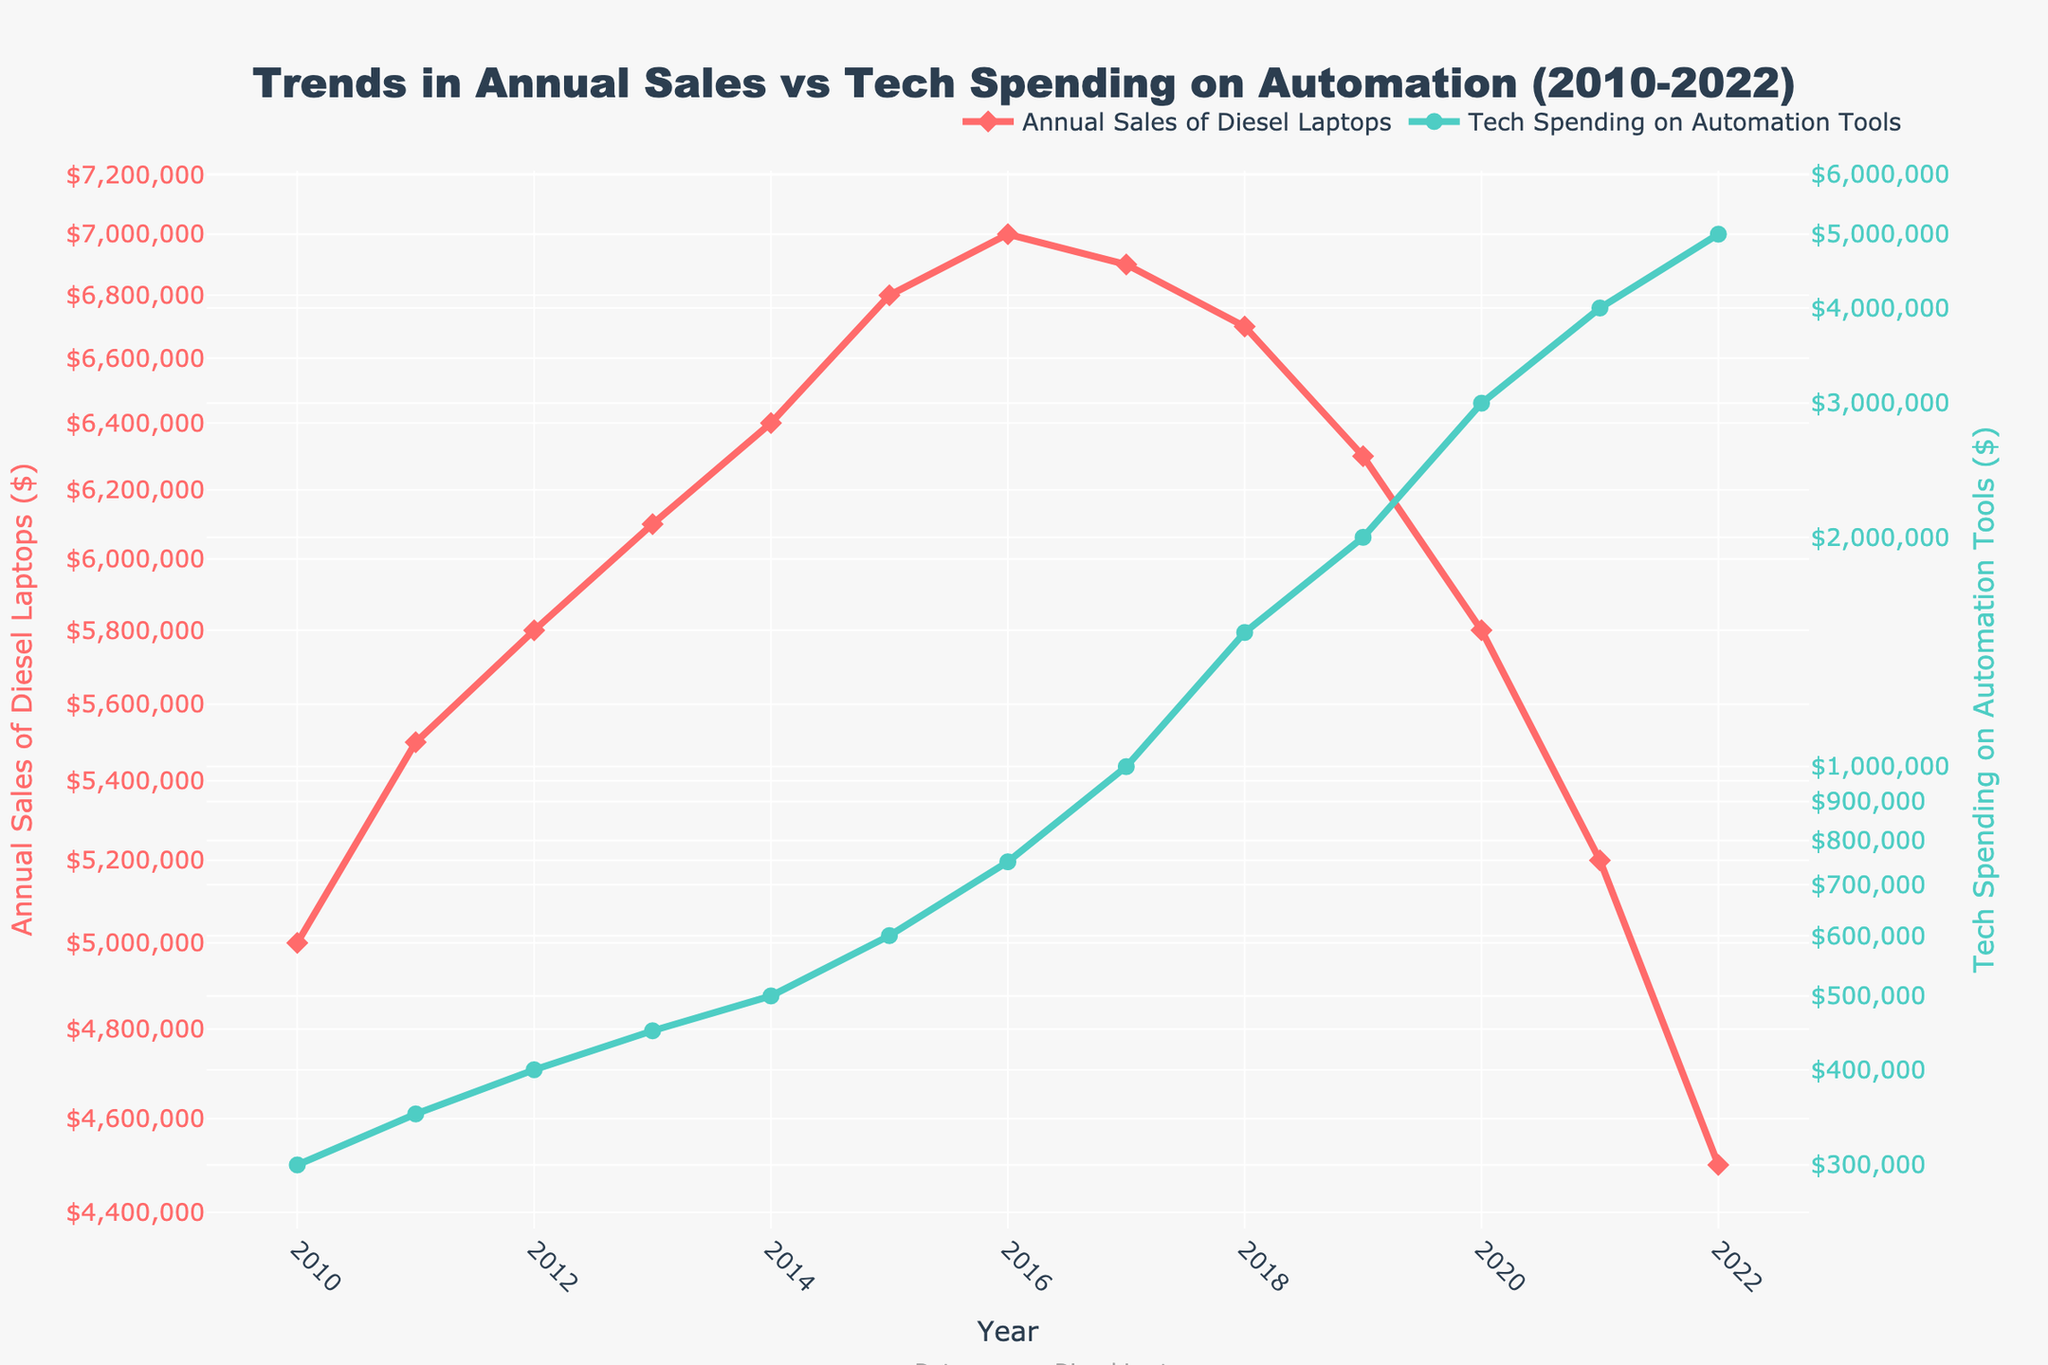What is the title of the plot? The title is positioned above the plot and is designed to give a summary of the data being visualized.
Answer: Trends in Annual Sales vs Tech Spending on Automation (2010-2022) How many data points are displayed for Annual Sales of Diesel Laptops? Each year from 2010 to 2022 is marked with a data point in the figure. Counting all the data points within the specified range provides the answer.
Answer: 13 What trend do you observe in Tech Spending on Automation Tools from 2015 to 2022? By examining the figure's log-scale axis, look at the trace for Tech Spending on Automation Tools. Observing the pattern from 2015 to 2022 shows the trend.
Answer: Increasing What was the annual sales value of Diesel Laptops in 2012? Find the data point for the year 2012 in the trace for Annual Sales of Diesel Laptops. The value is marked at this data point.
Answer: $5,800,000 In which year did Tech Spending on Automation Tools exceed $1,000,000 for the first time? Locate the point where the trace for Tech Spending on Automation Tools crosses the $1,000,000 mark on the log-scale axis. Identify the corresponding year.
Answer: 2017 What is the relationship between the trends in the two variables from 2018 to 2022? Analyze the patterns of both trends over these years. Annual Sales of Diesel Laptops appear to decrease, while Tech Spending on Automation Tools appears to increase.
Answer: Inversely proportional Which had a larger percentage change from 2010 to 2022, Annual Sales of Diesel Laptops or Tech Spending on Automation Tools? Calculate the percentage change for each:  
Annual Sales (2010 to 2022): ((4500000 - 5000000)/5000000) * 100 = -10%  
Tech Spending (2010 to 2022): ((5000000 - 300000)/300000) * 100 = 1566.67%
Answer: Tech Spending on Automation Tools What were the respective values for Annual Sales of Diesel Laptops and Tech Spending on Automation Tools in 2020? Locate the year 2020 and identify the respective values on both traces:  
Annual Sales: $5,800,000  
Tech Spending: $3,000,000
Answer: $5,800,000 and $3,000,000 How did the Annual Sales of Diesel Laptops change between 2015 and 2020? Review the values at 2015 ($6,800,000) and 2020 ($5,800,000). Identify the direction and amount of change.
Answer: Decreased by $1,000,000 What was the average Tech Spending on Automation Tools from 2010 to 2016? Compute the average over these years:  
(300000 + 350000 + 400000 + 450000 + 500000 + 600000 + 750000)/7 = 478571.43
Answer: $478,571.43 